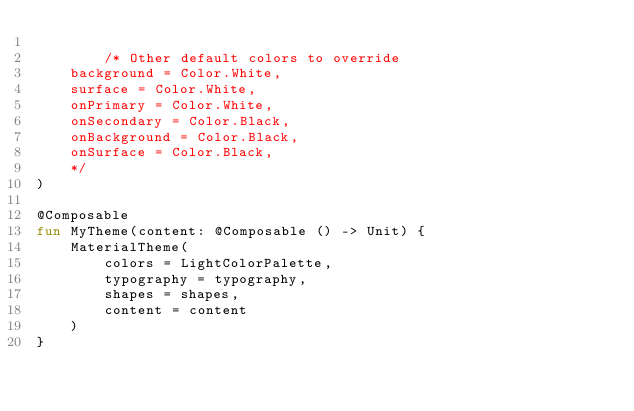Convert code to text. <code><loc_0><loc_0><loc_500><loc_500><_Kotlin_>
        /* Other default colors to override
    background = Color.White,
    surface = Color.White,
    onPrimary = Color.White,
    onSecondary = Color.Black,
    onBackground = Color.Black,
    onSurface = Color.Black,
    */
)

@Composable
fun MyTheme(content: @Composable () -> Unit) {
    MaterialTheme(
        colors = LightColorPalette,
        typography = typography,
        shapes = shapes,
        content = content
    )
}
</code> 